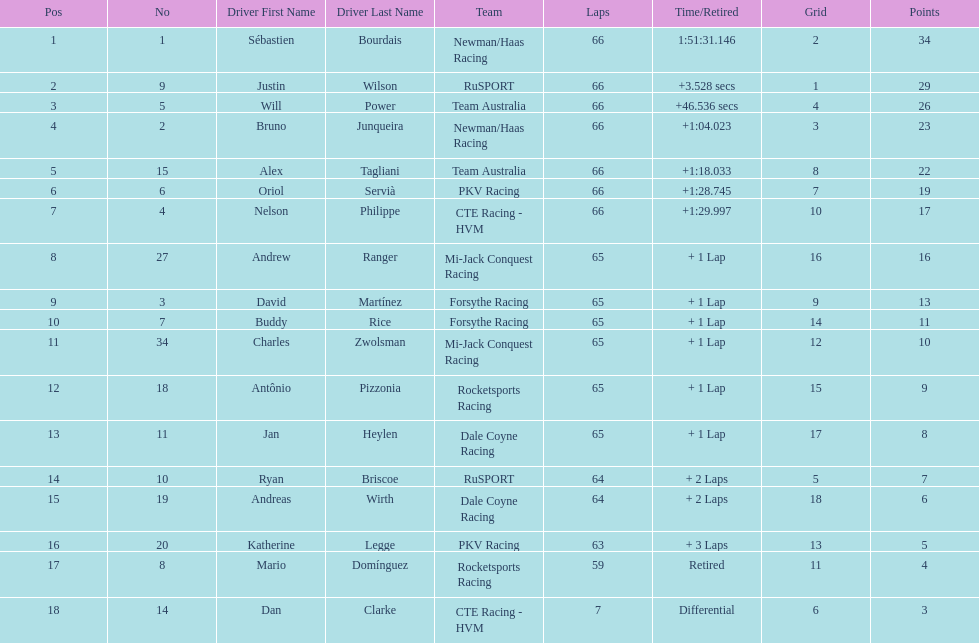Which country is represented by the most drivers? United Kingdom. 